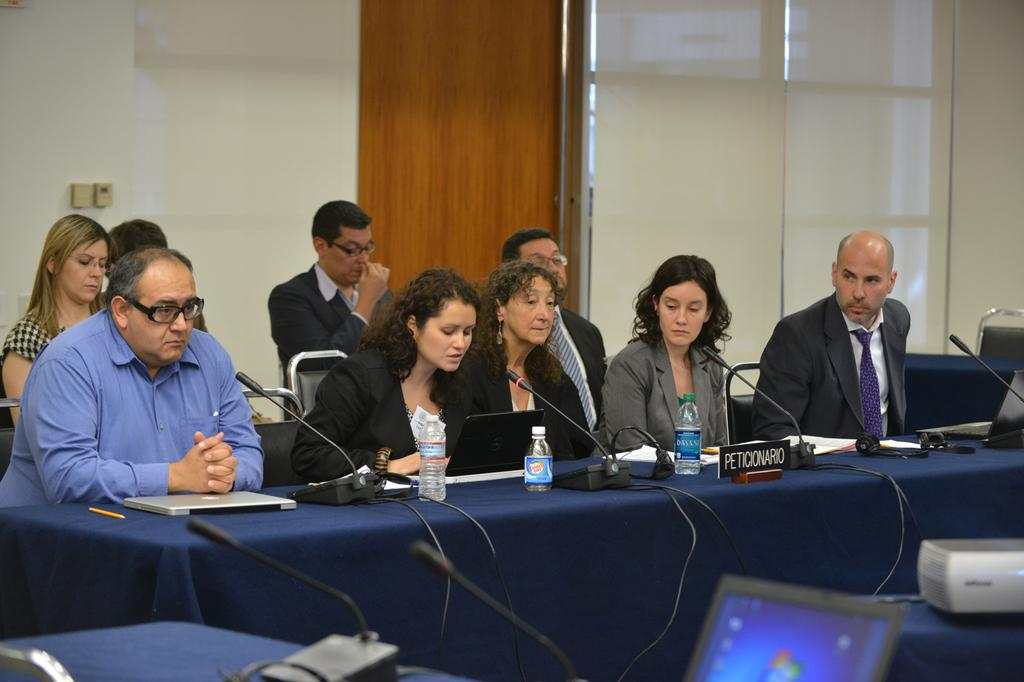How many people are in the image? There is a group of people in the image. What are the people doing in the image? The people are seated on chairs. What objects are in front of the people? There are microphones in front of the people. What items can be seen on the table in the image? There are bottles, laptops, and other things on the table. What type of polish is being applied to the cake in the image? There is no cake or polish present in the image. How far away is the nearest object from the people in the image? The provided facts do not give information about the distance between the people and objects in the image. 